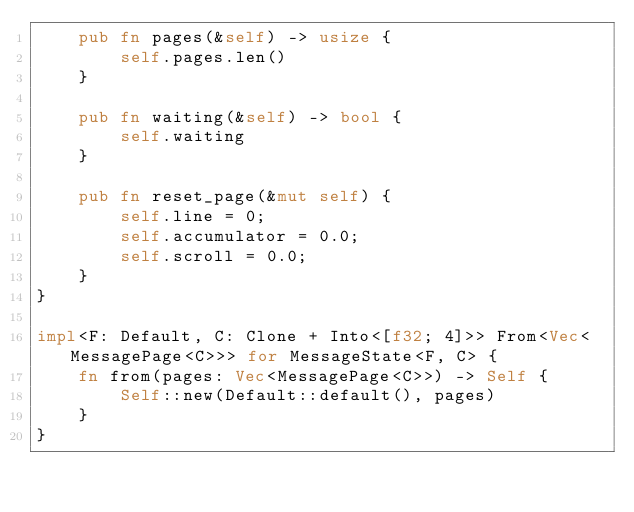<code> <loc_0><loc_0><loc_500><loc_500><_Rust_>    pub fn pages(&self) -> usize {
        self.pages.len()
    }

    pub fn waiting(&self) -> bool {
        self.waiting
    }

    pub fn reset_page(&mut self) {
        self.line = 0;
        self.accumulator = 0.0;
        self.scroll = 0.0;
    }
}

impl<F: Default, C: Clone + Into<[f32; 4]>> From<Vec<MessagePage<C>>> for MessageState<F, C> {
    fn from(pages: Vec<MessagePage<C>>) -> Self {
        Self::new(Default::default(), pages)
    }
}</code> 